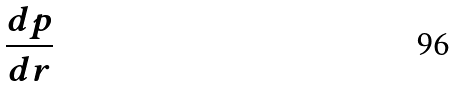<formula> <loc_0><loc_0><loc_500><loc_500>\frac { d p } { d r }</formula> 